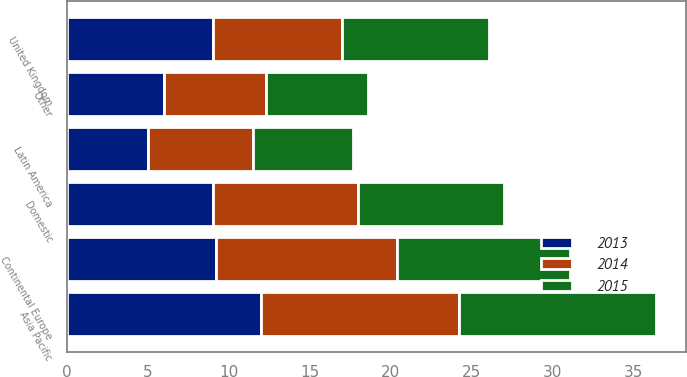Convert chart to OTSL. <chart><loc_0><loc_0><loc_500><loc_500><stacked_bar_chart><ecel><fcel>Domestic<fcel>United Kingdom<fcel>Continental Europe<fcel>Asia Pacific<fcel>Latin America<fcel>Other<nl><fcel>2013<fcel>9<fcel>9<fcel>9.2<fcel>12<fcel>5<fcel>6<nl><fcel>2015<fcel>9<fcel>9.1<fcel>10.7<fcel>12.2<fcel>6.2<fcel>6.3<nl><fcel>2014<fcel>9<fcel>8<fcel>11.2<fcel>12.2<fcel>6.5<fcel>6.3<nl></chart> 